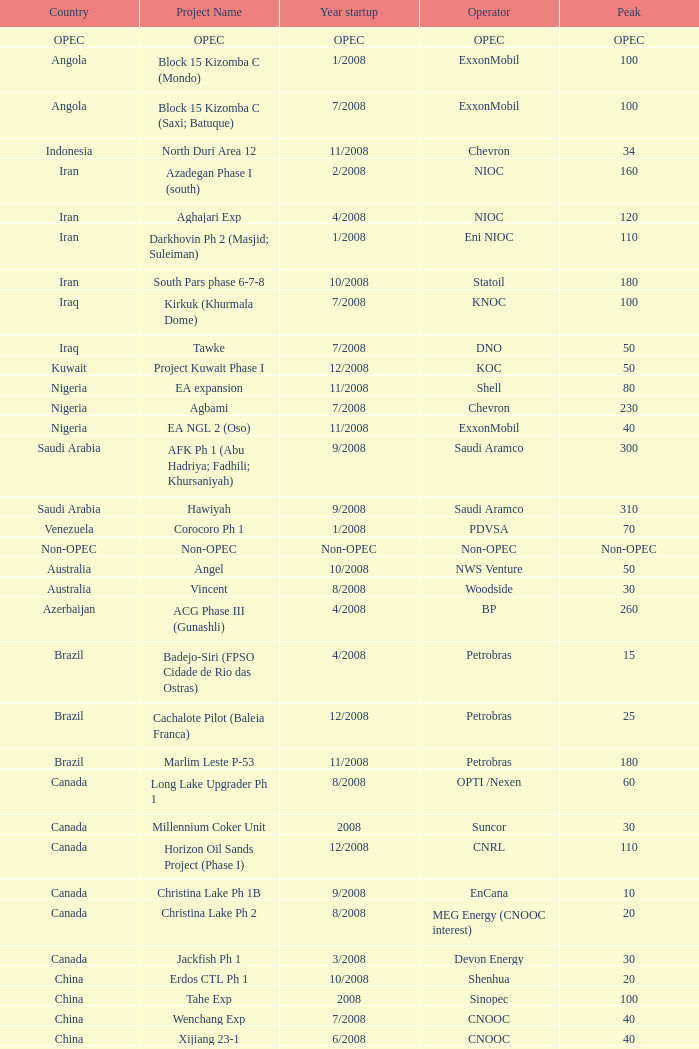What is the name of the project associated with kazakhstan as the country and a peak of 150? Dunga. 